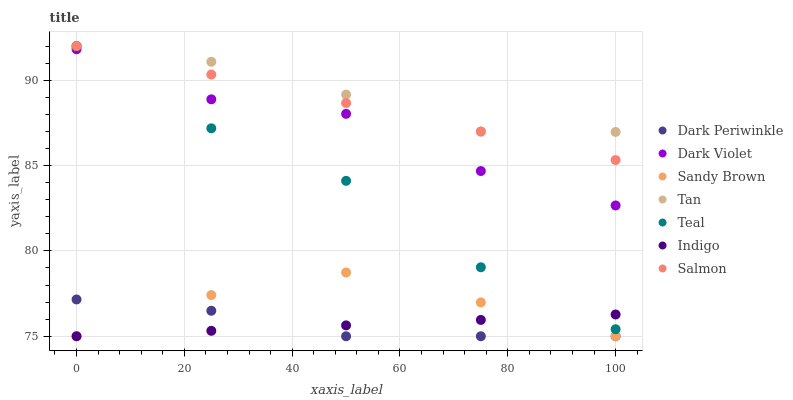Does Indigo have the minimum area under the curve?
Answer yes or no. Yes. Does Tan have the maximum area under the curve?
Answer yes or no. Yes. Does Salmon have the minimum area under the curve?
Answer yes or no. No. Does Salmon have the maximum area under the curve?
Answer yes or no. No. Is Indigo the smoothest?
Answer yes or no. Yes. Is Dark Violet the roughest?
Answer yes or no. Yes. Is Salmon the smoothest?
Answer yes or no. No. Is Salmon the roughest?
Answer yes or no. No. Does Indigo have the lowest value?
Answer yes or no. Yes. Does Salmon have the lowest value?
Answer yes or no. No. Does Tan have the highest value?
Answer yes or no. Yes. Does Dark Violet have the highest value?
Answer yes or no. No. Is Indigo less than Salmon?
Answer yes or no. Yes. Is Salmon greater than Dark Violet?
Answer yes or no. Yes. Does Indigo intersect Dark Periwinkle?
Answer yes or no. Yes. Is Indigo less than Dark Periwinkle?
Answer yes or no. No. Is Indigo greater than Dark Periwinkle?
Answer yes or no. No. Does Indigo intersect Salmon?
Answer yes or no. No. 